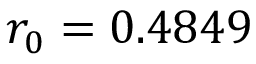<formula> <loc_0><loc_0><loc_500><loc_500>r _ { 0 } = 0 . 4 8 4 9</formula> 